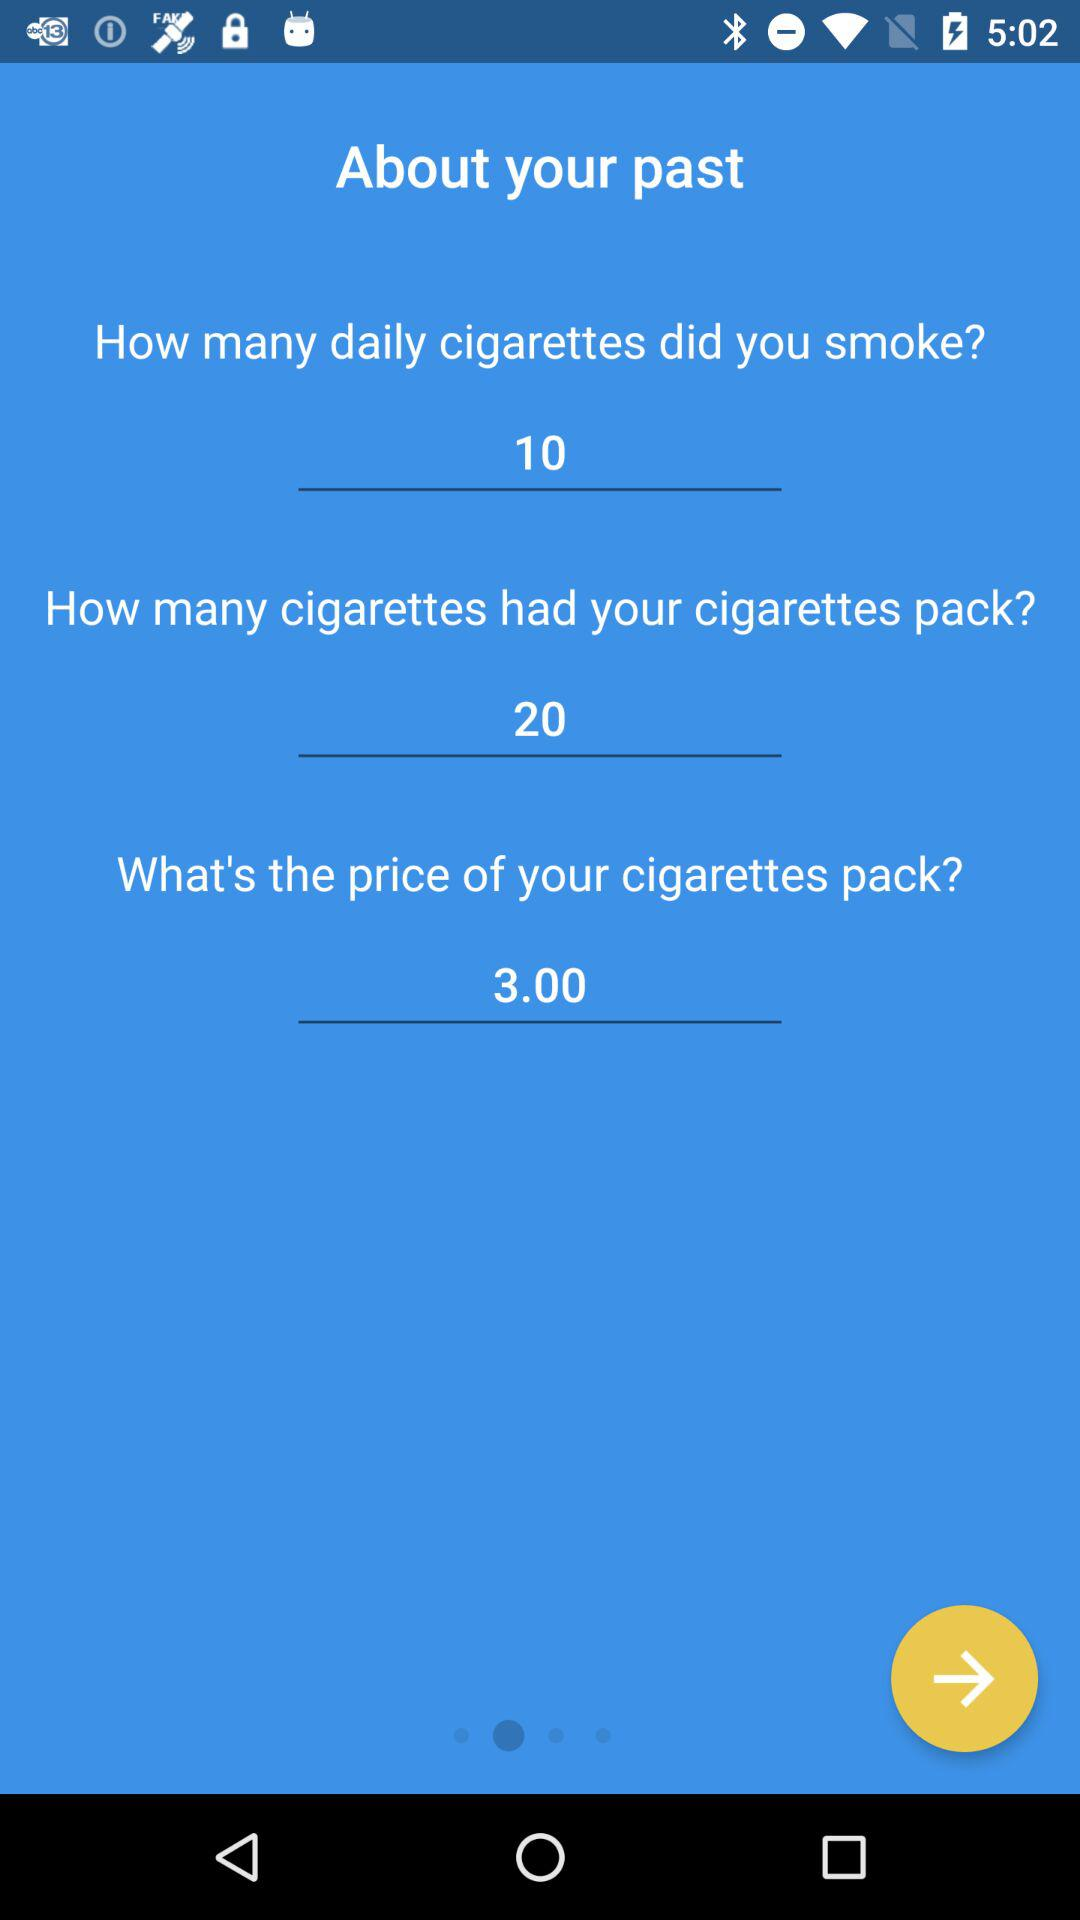How many cigarettes were in my cigarette pack? There were 20 cigarettes. 